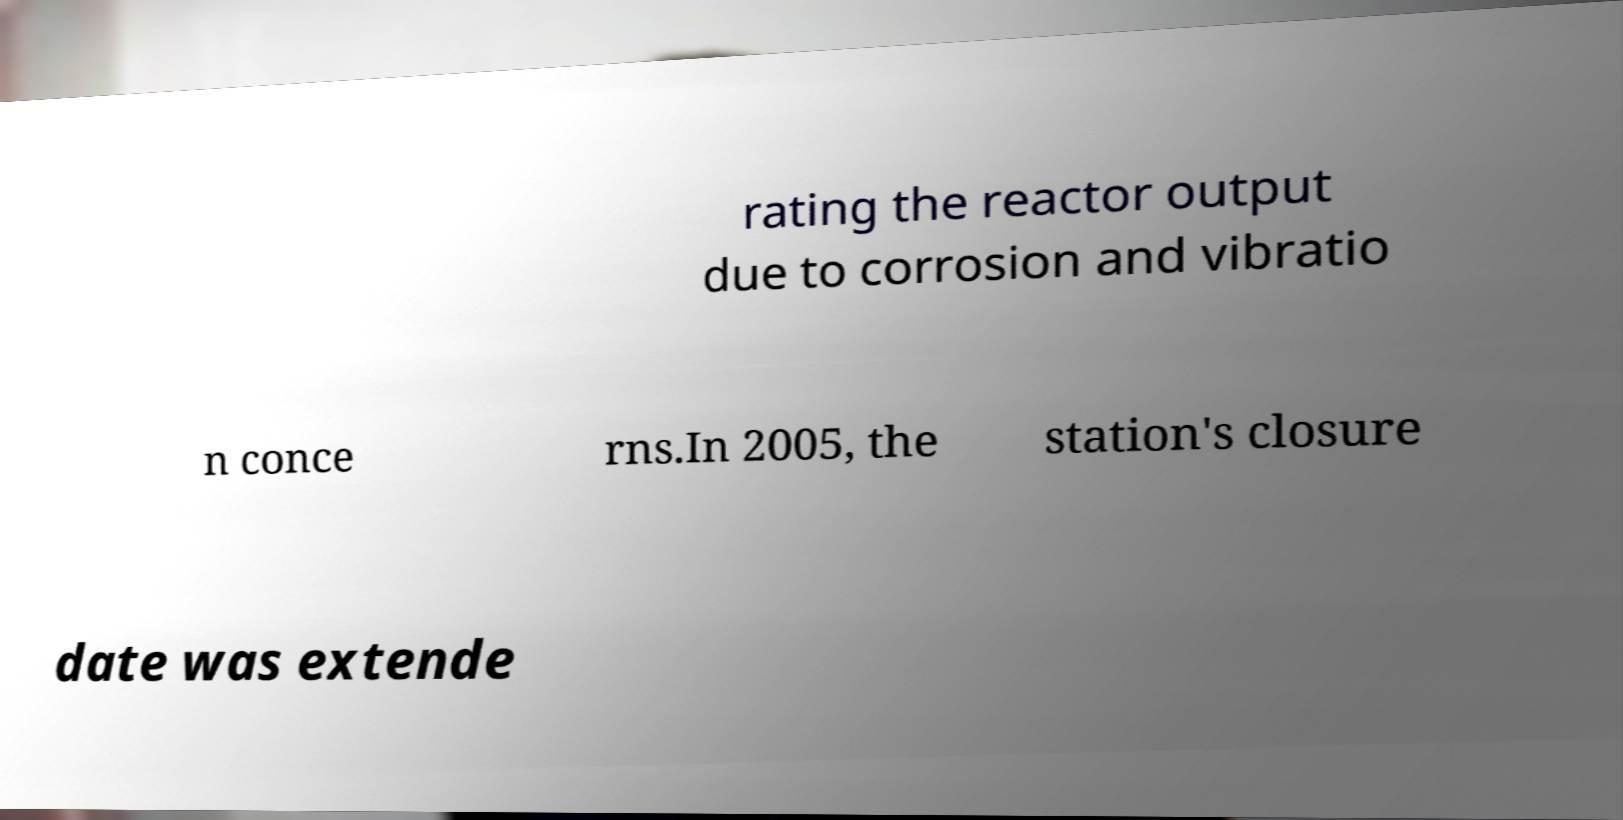I need the written content from this picture converted into text. Can you do that? rating the reactor output due to corrosion and vibratio n conce rns.In 2005, the station's closure date was extende 